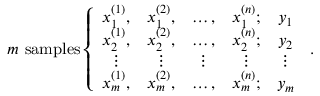<formula> <loc_0><loc_0><loc_500><loc_500>m \ s a m p l e s \left \{ \begin{array} { c c c c c } { x _ { 1 } ^ { ( 1 ) } , } & { x _ { 1 } ^ { ( 2 ) } , } & { \dots , } & { x _ { 1 } ^ { ( n ) } ; } & { y _ { 1 } } \\ { x _ { 2 } ^ { ( 1 ) } , } & { x _ { 2 } ^ { ( 2 ) } , } & { \dots , } & { x _ { 2 } ^ { ( n ) } ; } & { y _ { 2 } } \\ { \vdots } & { \vdots } & { \vdots } & { \vdots } & { \vdots } \\ { x _ { m } ^ { ( 1 ) } , } & { x _ { m } ^ { ( 2 ) } , } & { \dots , } & { x _ { m } ^ { ( n ) } ; } & { y _ { m } } \end{array} \, .</formula> 